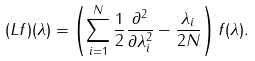<formula> <loc_0><loc_0><loc_500><loc_500>( L f ) ( \lambda ) = \left ( \sum _ { i = 1 } ^ { N } \frac { 1 } { 2 } \frac { \partial ^ { 2 } } { \partial \lambda _ { i } ^ { 2 } } - \frac { \lambda _ { i } } { 2 N } \right ) f ( \lambda ) .</formula> 